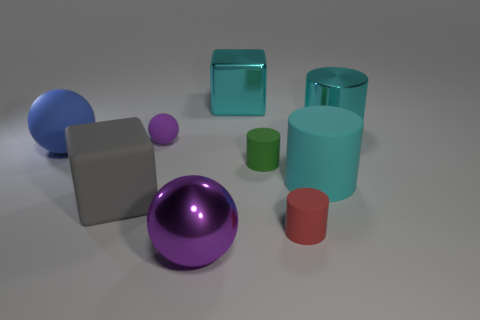Is the big cyan cylinder in front of the big blue object made of the same material as the big cyan cylinder that is behind the green thing?
Give a very brief answer. No. The block that is in front of the big block to the right of the large purple shiny thing is made of what material?
Your answer should be very brief. Rubber. There is a cyan object that is to the left of the large cyan object in front of the matte cylinder that is to the left of the red rubber cylinder; what is its size?
Keep it short and to the point. Large. Is the red rubber cylinder the same size as the cyan matte cylinder?
Your response must be concise. No. Is the shape of the large metallic thing in front of the large matte cylinder the same as the large cyan thing that is in front of the big blue rubber thing?
Your answer should be very brief. No. There is a big cylinder on the right side of the large rubber cylinder; is there a cyan metal cylinder that is to the right of it?
Give a very brief answer. No. Is there a rubber cube?
Your response must be concise. Yes. What number of rubber objects are the same size as the green cylinder?
Ensure brevity in your answer.  2. How many objects are right of the tiny purple thing and behind the blue matte thing?
Ensure brevity in your answer.  2. There is a rubber object that is behind the blue rubber sphere; does it have the same size as the cyan cube?
Your response must be concise. No. 